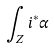Convert formula to latex. <formula><loc_0><loc_0><loc_500><loc_500>\int _ { Z } i ^ { * } \alpha</formula> 